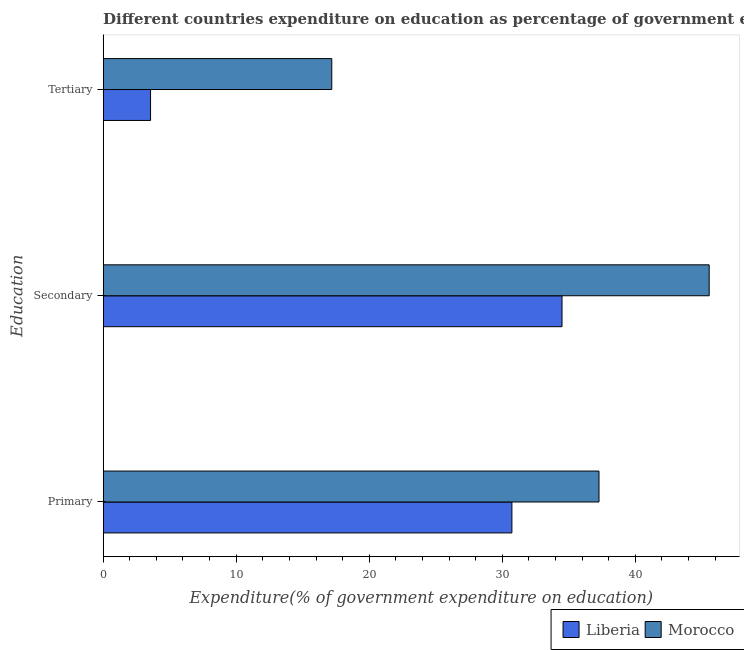How many different coloured bars are there?
Make the answer very short. 2. Are the number of bars per tick equal to the number of legend labels?
Your answer should be compact. Yes. How many bars are there on the 3rd tick from the top?
Ensure brevity in your answer.  2. How many bars are there on the 2nd tick from the bottom?
Offer a terse response. 2. What is the label of the 2nd group of bars from the top?
Provide a succinct answer. Secondary. What is the expenditure on primary education in Morocco?
Make the answer very short. 37.27. Across all countries, what is the maximum expenditure on secondary education?
Your response must be concise. 45.55. Across all countries, what is the minimum expenditure on primary education?
Make the answer very short. 30.72. In which country was the expenditure on primary education maximum?
Your answer should be very brief. Morocco. In which country was the expenditure on tertiary education minimum?
Offer a very short reply. Liberia. What is the total expenditure on secondary education in the graph?
Your answer should be very brief. 80.04. What is the difference between the expenditure on tertiary education in Morocco and that in Liberia?
Keep it short and to the point. 13.62. What is the difference between the expenditure on tertiary education in Morocco and the expenditure on secondary education in Liberia?
Ensure brevity in your answer.  -17.31. What is the average expenditure on primary education per country?
Provide a succinct answer. 33.99. What is the difference between the expenditure on secondary education and expenditure on primary education in Morocco?
Your response must be concise. 8.28. In how many countries, is the expenditure on tertiary education greater than 10 %?
Offer a terse response. 1. What is the ratio of the expenditure on primary education in Morocco to that in Liberia?
Your answer should be compact. 1.21. What is the difference between the highest and the second highest expenditure on primary education?
Your response must be concise. 6.55. What is the difference between the highest and the lowest expenditure on secondary education?
Ensure brevity in your answer.  11.06. In how many countries, is the expenditure on tertiary education greater than the average expenditure on tertiary education taken over all countries?
Keep it short and to the point. 1. What does the 2nd bar from the top in Tertiary represents?
Keep it short and to the point. Liberia. What does the 2nd bar from the bottom in Tertiary represents?
Ensure brevity in your answer.  Morocco. How many bars are there?
Your answer should be compact. 6. Are all the bars in the graph horizontal?
Offer a terse response. Yes. How many countries are there in the graph?
Make the answer very short. 2. Are the values on the major ticks of X-axis written in scientific E-notation?
Your answer should be very brief. No. Where does the legend appear in the graph?
Provide a short and direct response. Bottom right. What is the title of the graph?
Offer a very short reply. Different countries expenditure on education as percentage of government expenditure. Does "Low & middle income" appear as one of the legend labels in the graph?
Give a very brief answer. No. What is the label or title of the X-axis?
Offer a very short reply. Expenditure(% of government expenditure on education). What is the label or title of the Y-axis?
Provide a short and direct response. Education. What is the Expenditure(% of government expenditure on education) of Liberia in Primary?
Offer a very short reply. 30.72. What is the Expenditure(% of government expenditure on education) of Morocco in Primary?
Your answer should be very brief. 37.27. What is the Expenditure(% of government expenditure on education) in Liberia in Secondary?
Keep it short and to the point. 34.49. What is the Expenditure(% of government expenditure on education) of Morocco in Secondary?
Provide a short and direct response. 45.55. What is the Expenditure(% of government expenditure on education) in Liberia in Tertiary?
Your answer should be compact. 3.56. What is the Expenditure(% of government expenditure on education) of Morocco in Tertiary?
Ensure brevity in your answer.  17.18. Across all Education, what is the maximum Expenditure(% of government expenditure on education) of Liberia?
Make the answer very short. 34.49. Across all Education, what is the maximum Expenditure(% of government expenditure on education) of Morocco?
Your answer should be very brief. 45.55. Across all Education, what is the minimum Expenditure(% of government expenditure on education) in Liberia?
Offer a very short reply. 3.56. Across all Education, what is the minimum Expenditure(% of government expenditure on education) of Morocco?
Provide a short and direct response. 17.18. What is the total Expenditure(% of government expenditure on education) of Liberia in the graph?
Give a very brief answer. 68.77. What is the total Expenditure(% of government expenditure on education) of Morocco in the graph?
Your response must be concise. 100. What is the difference between the Expenditure(% of government expenditure on education) of Liberia in Primary and that in Secondary?
Provide a short and direct response. -3.77. What is the difference between the Expenditure(% of government expenditure on education) in Morocco in Primary and that in Secondary?
Keep it short and to the point. -8.28. What is the difference between the Expenditure(% of government expenditure on education) in Liberia in Primary and that in Tertiary?
Provide a short and direct response. 27.16. What is the difference between the Expenditure(% of government expenditure on education) in Morocco in Primary and that in Tertiary?
Your answer should be very brief. 20.08. What is the difference between the Expenditure(% of government expenditure on education) of Liberia in Secondary and that in Tertiary?
Your answer should be very brief. 30.93. What is the difference between the Expenditure(% of government expenditure on education) in Morocco in Secondary and that in Tertiary?
Provide a short and direct response. 28.37. What is the difference between the Expenditure(% of government expenditure on education) of Liberia in Primary and the Expenditure(% of government expenditure on education) of Morocco in Secondary?
Your answer should be very brief. -14.83. What is the difference between the Expenditure(% of government expenditure on education) in Liberia in Primary and the Expenditure(% of government expenditure on education) in Morocco in Tertiary?
Keep it short and to the point. 13.54. What is the difference between the Expenditure(% of government expenditure on education) in Liberia in Secondary and the Expenditure(% of government expenditure on education) in Morocco in Tertiary?
Give a very brief answer. 17.31. What is the average Expenditure(% of government expenditure on education) of Liberia per Education?
Keep it short and to the point. 22.92. What is the average Expenditure(% of government expenditure on education) in Morocco per Education?
Your answer should be very brief. 33.33. What is the difference between the Expenditure(% of government expenditure on education) of Liberia and Expenditure(% of government expenditure on education) of Morocco in Primary?
Provide a succinct answer. -6.55. What is the difference between the Expenditure(% of government expenditure on education) in Liberia and Expenditure(% of government expenditure on education) in Morocco in Secondary?
Your answer should be compact. -11.06. What is the difference between the Expenditure(% of government expenditure on education) of Liberia and Expenditure(% of government expenditure on education) of Morocco in Tertiary?
Provide a succinct answer. -13.62. What is the ratio of the Expenditure(% of government expenditure on education) in Liberia in Primary to that in Secondary?
Your answer should be very brief. 0.89. What is the ratio of the Expenditure(% of government expenditure on education) of Morocco in Primary to that in Secondary?
Offer a very short reply. 0.82. What is the ratio of the Expenditure(% of government expenditure on education) in Liberia in Primary to that in Tertiary?
Provide a succinct answer. 8.62. What is the ratio of the Expenditure(% of government expenditure on education) of Morocco in Primary to that in Tertiary?
Give a very brief answer. 2.17. What is the ratio of the Expenditure(% of government expenditure on education) of Liberia in Secondary to that in Tertiary?
Provide a succinct answer. 9.68. What is the ratio of the Expenditure(% of government expenditure on education) in Morocco in Secondary to that in Tertiary?
Provide a succinct answer. 2.65. What is the difference between the highest and the second highest Expenditure(% of government expenditure on education) in Liberia?
Offer a very short reply. 3.77. What is the difference between the highest and the second highest Expenditure(% of government expenditure on education) of Morocco?
Your answer should be compact. 8.28. What is the difference between the highest and the lowest Expenditure(% of government expenditure on education) of Liberia?
Your response must be concise. 30.93. What is the difference between the highest and the lowest Expenditure(% of government expenditure on education) in Morocco?
Offer a terse response. 28.37. 